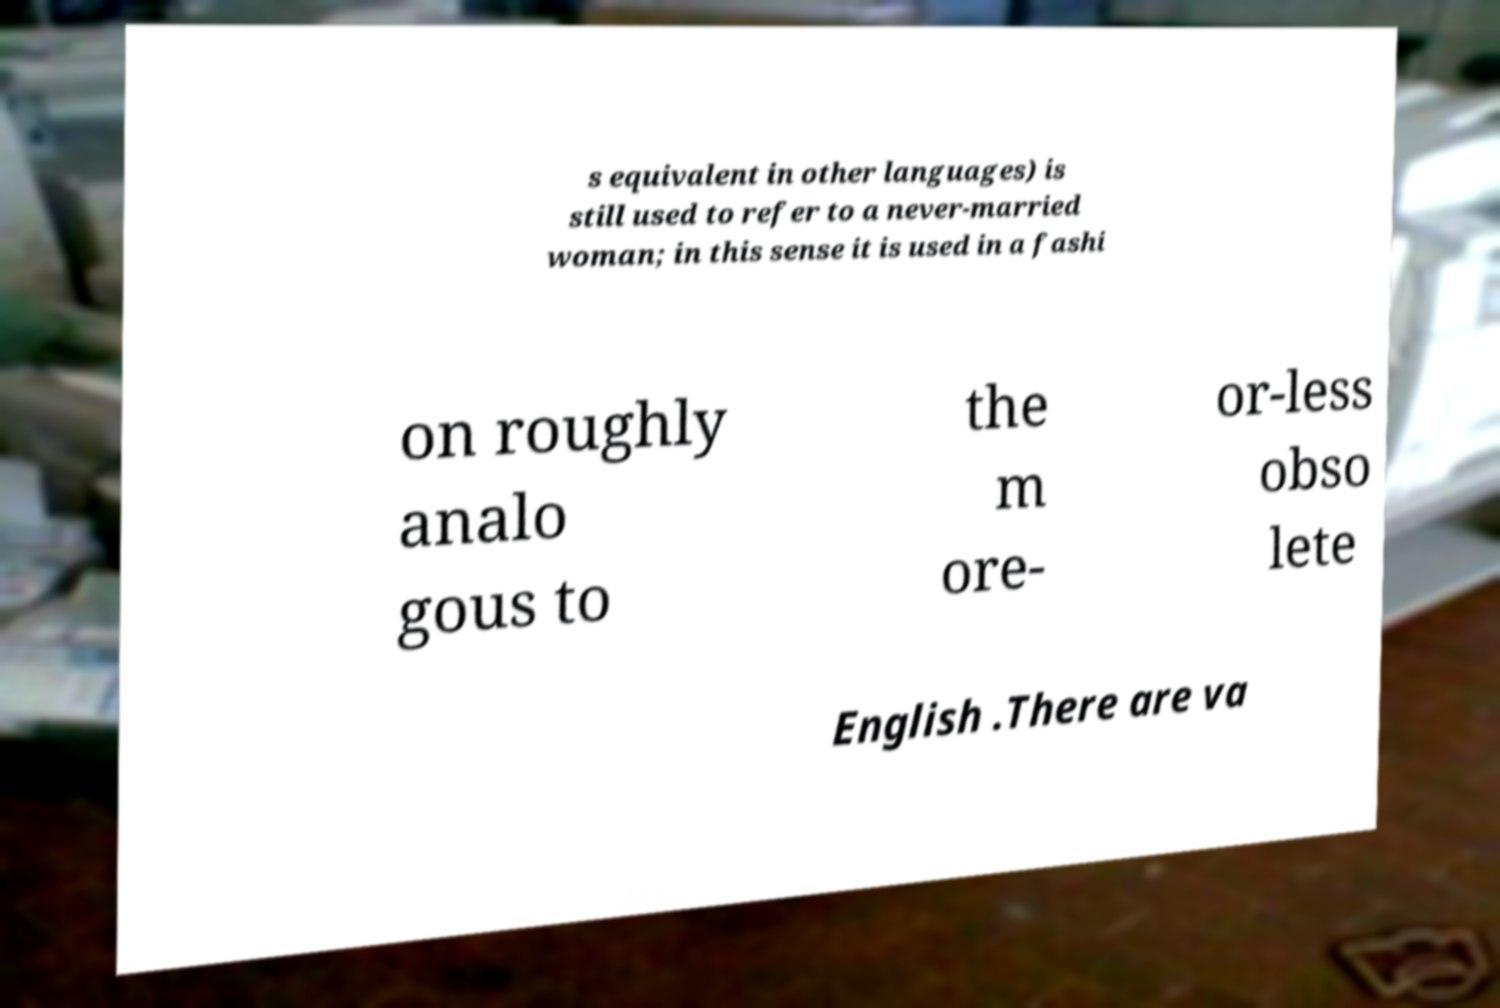Please read and relay the text visible in this image. What does it say? s equivalent in other languages) is still used to refer to a never-married woman; in this sense it is used in a fashi on roughly analo gous to the m ore- or-less obso lete English .There are va 